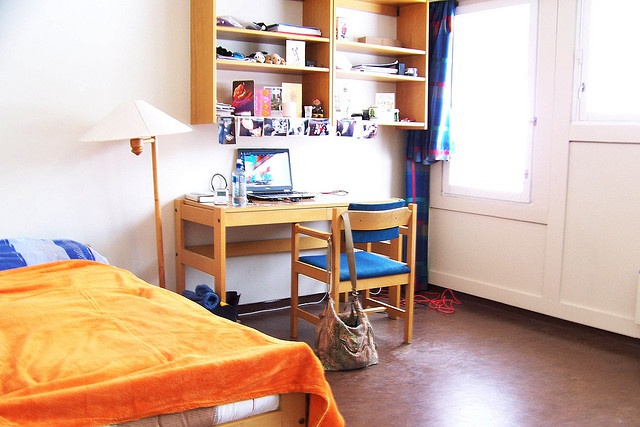Describe the objects in this image and their specific colors. I can see bed in lavender, gold, red, orange, and khaki tones, chair in lavender, tan, brown, maroon, and black tones, handbag in lavender, maroon, brown, and gray tones, laptop in lavender, white, gray, darkgray, and black tones, and book in lavender, ivory, tan, maroon, and black tones in this image. 